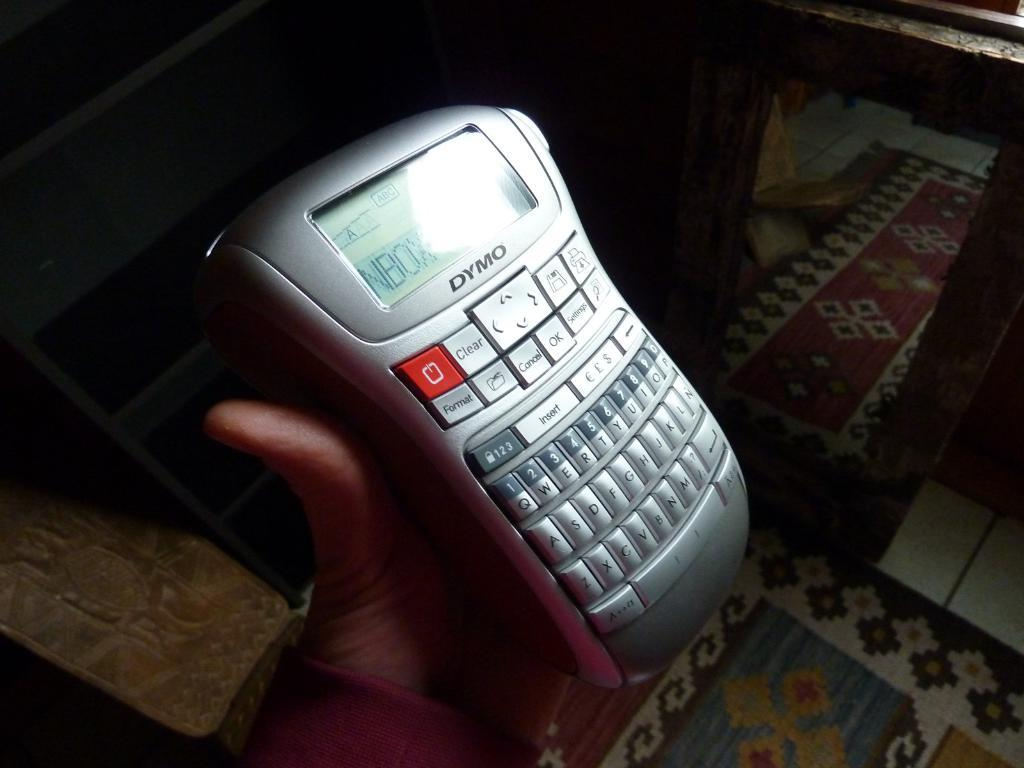What is the main subject of the image? There is a person in the image. What is the person holding in the image? The person is holding an electronic gadget. What can be seen at the top of the image? There are bag-like objects at the top of the image. What is visible on the right side of the image? There is a window on the right side of the image. What type of engine can be seen in the image? There is no engine present in the image. What is the person having for dinner in the image? The image does not show the person having dinner, so it cannot be determined from the image. 